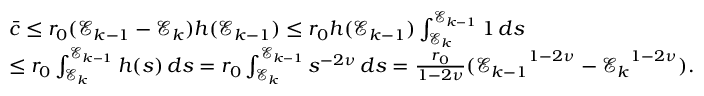Convert formula to latex. <formula><loc_0><loc_0><loc_500><loc_500>\begin{array} { r l } & { \bar { c } \leq r _ { 0 } ( \mathcal { E } _ { k - 1 } - \mathcal { E } _ { k } ) h ( \mathcal { E } _ { k - 1 } ) \leq r _ { 0 } h ( \mathcal { E } _ { k - 1 } ) \int _ { \mathcal { E } _ { k } } ^ { \mathcal { E } _ { k - 1 } } { 1 \, d s } } \\ & { \leq r _ { 0 } \int _ { \mathcal { E } _ { k } } ^ { \mathcal { E } _ { k - 1 } } { h ( s ) \, d s } = r _ { 0 } \int _ { \mathcal { E } _ { k } } ^ { \mathcal { E } _ { k - 1 } } { s ^ { - 2 \nu } \, d s } = \frac { r _ { 0 } } { 1 - 2 \nu } ( { \mathcal { E } _ { k - 1 } } ^ { 1 - 2 \nu } - { \mathcal { E } _ { k } } ^ { 1 - 2 \nu } ) . } \end{array}</formula> 